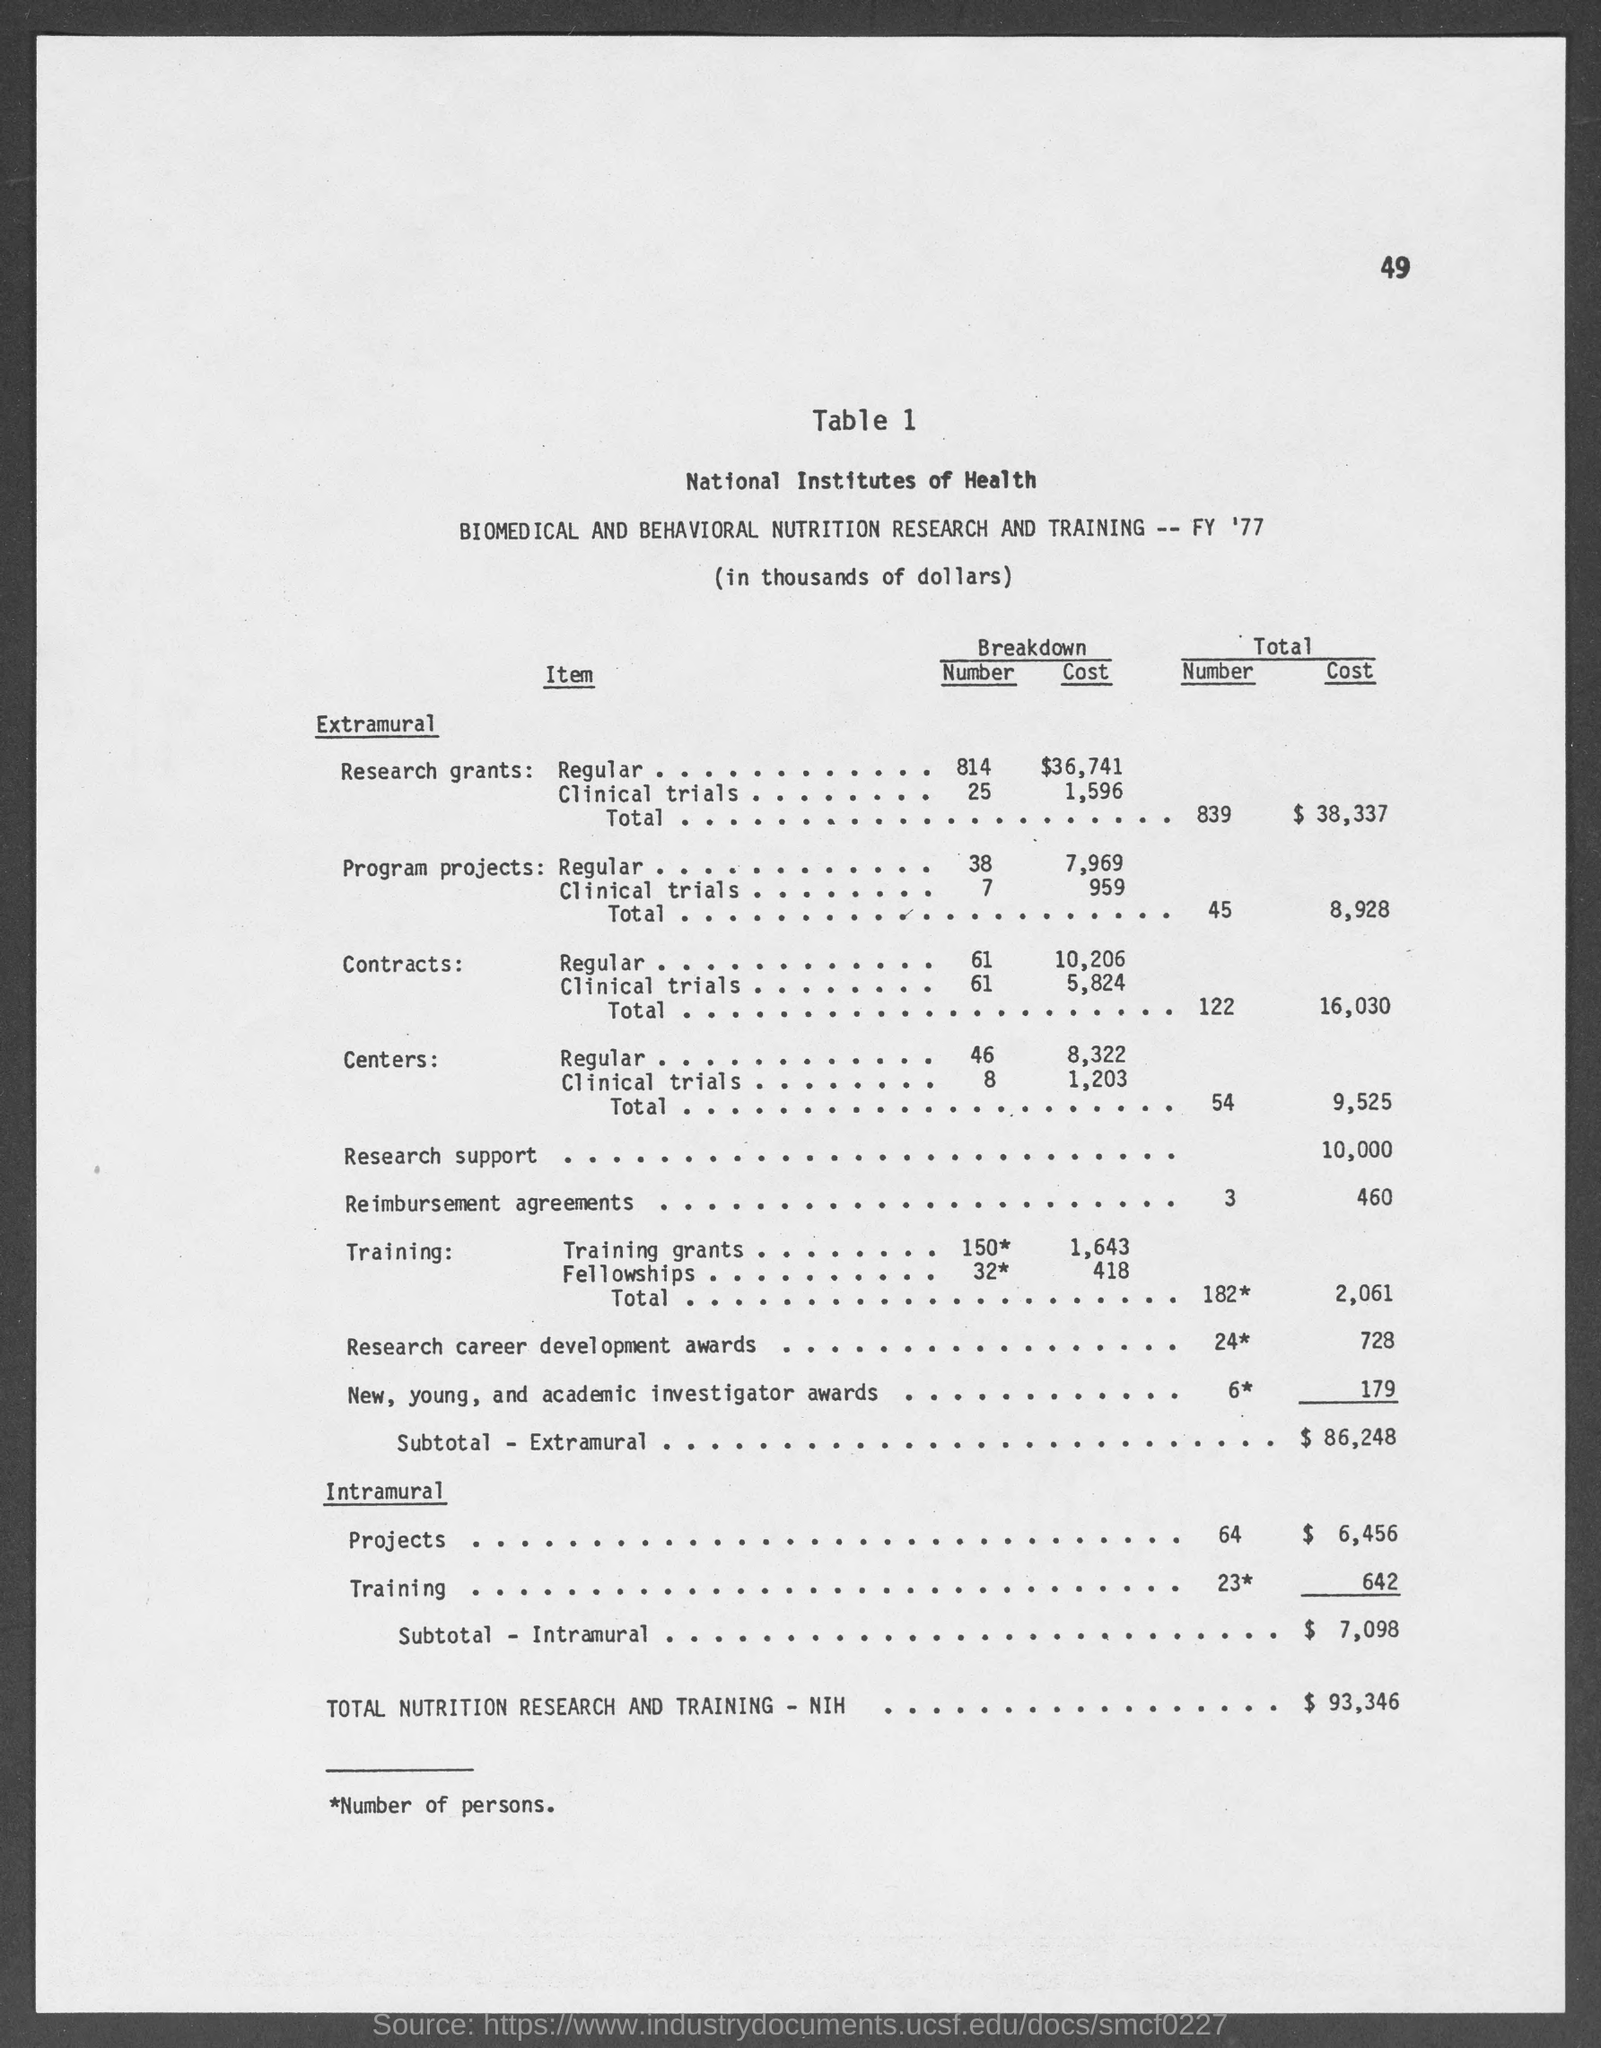What is the page number at top of the page?
Provide a short and direct response. 49. What is the total cost of extramural research grants ?
Offer a very short reply. $38,337. What is the total cost of extramural program projects ?
Ensure brevity in your answer.  8,928. What is the total cost of extramural contracts ?
Give a very brief answer. 16,030. What is the total cost of extramural centers ?
Your answer should be very brief. 9,525. What is the total cost of extramural research support ?
Offer a terse response. 10,000. What is the total cost of extramural reimbursement agreements ?
Keep it short and to the point. 460. What is the total cost of intramural projects ?
Keep it short and to the point. $6,456. What is the total cost of intramural training?
Offer a very short reply. $642. 